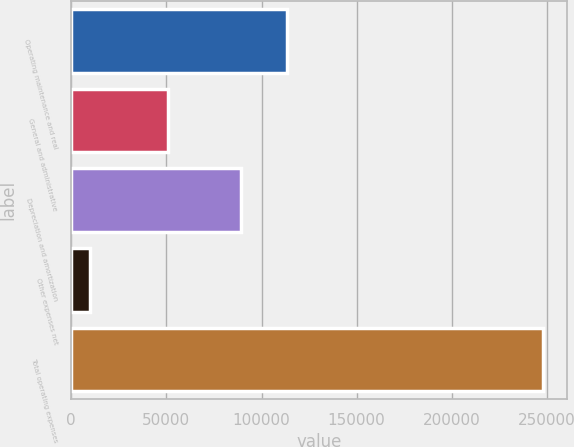Convert chart to OTSL. <chart><loc_0><loc_0><loc_500><loc_500><bar_chart><fcel>Operating maintenance and real<fcel>General and administrative<fcel>Depreciation and amortization<fcel>Other expenses net<fcel>Total operating expenses<nl><fcel>113150<fcel>50580<fcel>89365<fcel>10057<fcel>247912<nl></chart> 